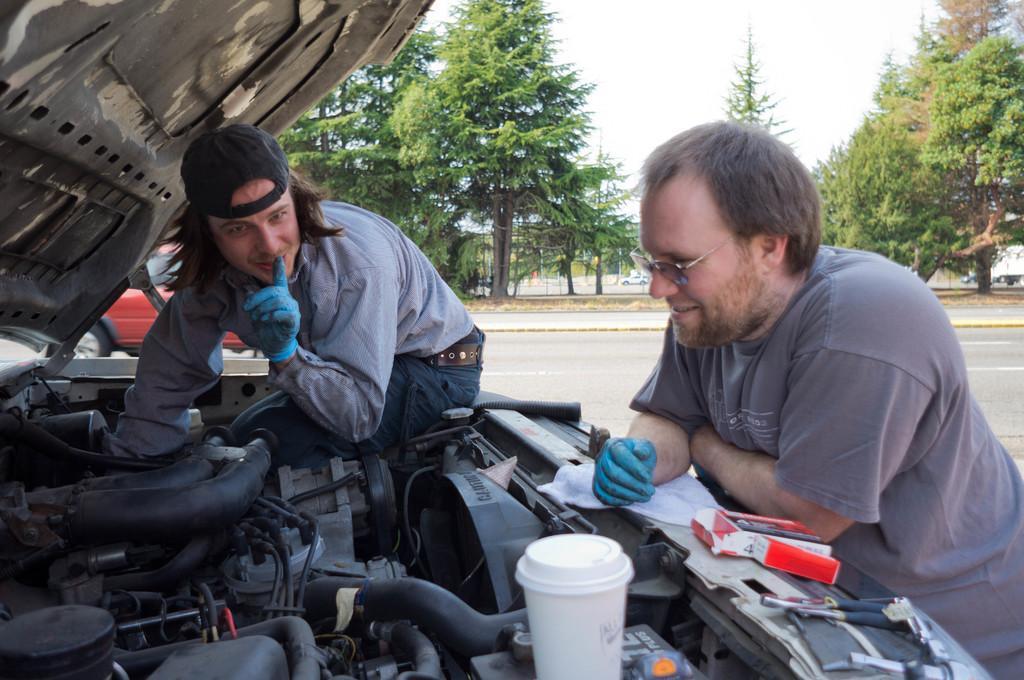In one or two sentences, can you explain what this image depicts? In this image there is a person sitting on the bonnet of the car is fixing the car engine, beside him there is another person standing in front of the car, there is a cup and a few tools on the bonnet of the car, behind them there is a car passing on the road, in the background of the image there are trees. 